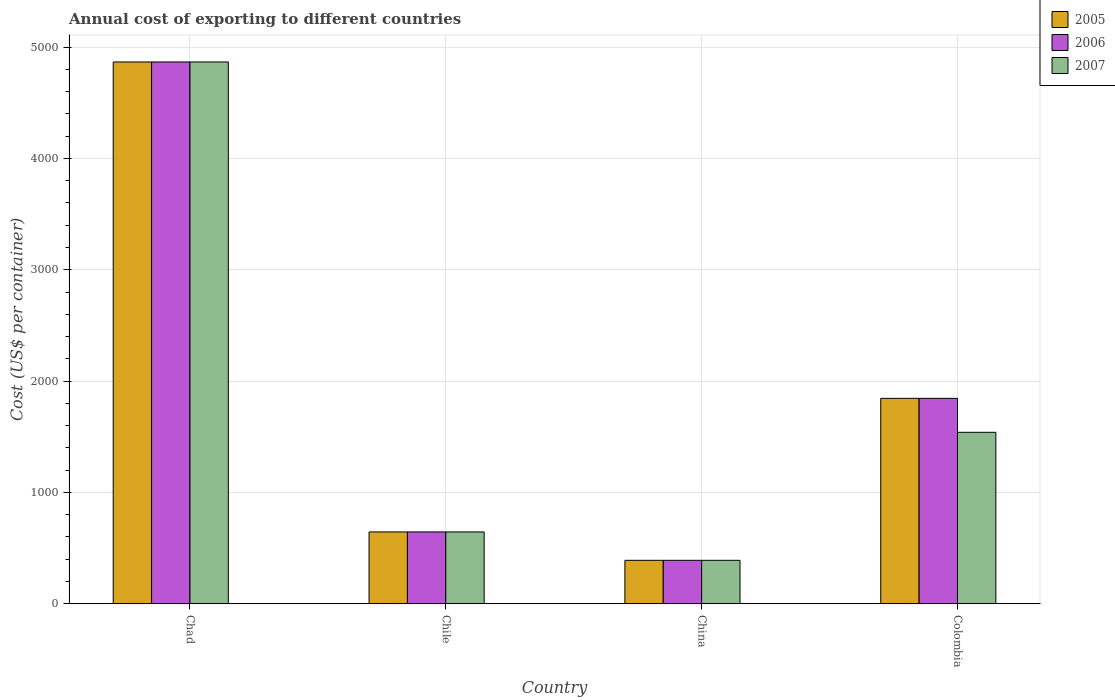How many different coloured bars are there?
Your answer should be compact. 3. How many groups of bars are there?
Offer a terse response. 4. Are the number of bars on each tick of the X-axis equal?
Make the answer very short. Yes. How many bars are there on the 4th tick from the left?
Give a very brief answer. 3. What is the label of the 1st group of bars from the left?
Make the answer very short. Chad. In how many cases, is the number of bars for a given country not equal to the number of legend labels?
Offer a very short reply. 0. What is the total annual cost of exporting in 2006 in Colombia?
Give a very brief answer. 1845. Across all countries, what is the maximum total annual cost of exporting in 2007?
Your answer should be compact. 4867. Across all countries, what is the minimum total annual cost of exporting in 2006?
Your answer should be compact. 390. In which country was the total annual cost of exporting in 2007 maximum?
Provide a short and direct response. Chad. In which country was the total annual cost of exporting in 2007 minimum?
Provide a short and direct response. China. What is the total total annual cost of exporting in 2007 in the graph?
Your response must be concise. 7442. What is the difference between the total annual cost of exporting in 2006 in Chile and that in China?
Your response must be concise. 255. What is the difference between the total annual cost of exporting in 2005 in Chad and the total annual cost of exporting in 2006 in Chile?
Make the answer very short. 4222. What is the average total annual cost of exporting in 2007 per country?
Provide a short and direct response. 1860.5. What is the ratio of the total annual cost of exporting in 2005 in Chad to that in China?
Offer a very short reply. 12.48. Is the total annual cost of exporting in 2006 in Chad less than that in China?
Ensure brevity in your answer.  No. What is the difference between the highest and the second highest total annual cost of exporting in 2007?
Your response must be concise. 3327. What is the difference between the highest and the lowest total annual cost of exporting in 2007?
Give a very brief answer. 4477. In how many countries, is the total annual cost of exporting in 2006 greater than the average total annual cost of exporting in 2006 taken over all countries?
Give a very brief answer. 1. Is the sum of the total annual cost of exporting in 2007 in China and Colombia greater than the maximum total annual cost of exporting in 2005 across all countries?
Provide a short and direct response. No. Is it the case that in every country, the sum of the total annual cost of exporting in 2007 and total annual cost of exporting in 2005 is greater than the total annual cost of exporting in 2006?
Keep it short and to the point. Yes. Are all the bars in the graph horizontal?
Give a very brief answer. No. What is the title of the graph?
Make the answer very short. Annual cost of exporting to different countries. What is the label or title of the X-axis?
Your response must be concise. Country. What is the label or title of the Y-axis?
Your answer should be very brief. Cost (US$ per container). What is the Cost (US$ per container) in 2005 in Chad?
Give a very brief answer. 4867. What is the Cost (US$ per container) in 2006 in Chad?
Provide a short and direct response. 4867. What is the Cost (US$ per container) in 2007 in Chad?
Make the answer very short. 4867. What is the Cost (US$ per container) in 2005 in Chile?
Your answer should be compact. 645. What is the Cost (US$ per container) of 2006 in Chile?
Your answer should be compact. 645. What is the Cost (US$ per container) of 2007 in Chile?
Give a very brief answer. 645. What is the Cost (US$ per container) in 2005 in China?
Ensure brevity in your answer.  390. What is the Cost (US$ per container) of 2006 in China?
Your response must be concise. 390. What is the Cost (US$ per container) in 2007 in China?
Make the answer very short. 390. What is the Cost (US$ per container) in 2005 in Colombia?
Your answer should be compact. 1845. What is the Cost (US$ per container) of 2006 in Colombia?
Provide a short and direct response. 1845. What is the Cost (US$ per container) in 2007 in Colombia?
Your response must be concise. 1540. Across all countries, what is the maximum Cost (US$ per container) in 2005?
Your answer should be very brief. 4867. Across all countries, what is the maximum Cost (US$ per container) of 2006?
Your answer should be very brief. 4867. Across all countries, what is the maximum Cost (US$ per container) of 2007?
Your answer should be very brief. 4867. Across all countries, what is the minimum Cost (US$ per container) of 2005?
Offer a very short reply. 390. Across all countries, what is the minimum Cost (US$ per container) in 2006?
Provide a short and direct response. 390. Across all countries, what is the minimum Cost (US$ per container) of 2007?
Provide a succinct answer. 390. What is the total Cost (US$ per container) in 2005 in the graph?
Provide a short and direct response. 7747. What is the total Cost (US$ per container) of 2006 in the graph?
Your answer should be compact. 7747. What is the total Cost (US$ per container) in 2007 in the graph?
Offer a very short reply. 7442. What is the difference between the Cost (US$ per container) in 2005 in Chad and that in Chile?
Your answer should be compact. 4222. What is the difference between the Cost (US$ per container) in 2006 in Chad and that in Chile?
Provide a succinct answer. 4222. What is the difference between the Cost (US$ per container) of 2007 in Chad and that in Chile?
Your answer should be compact. 4222. What is the difference between the Cost (US$ per container) in 2005 in Chad and that in China?
Your response must be concise. 4477. What is the difference between the Cost (US$ per container) of 2006 in Chad and that in China?
Give a very brief answer. 4477. What is the difference between the Cost (US$ per container) in 2007 in Chad and that in China?
Give a very brief answer. 4477. What is the difference between the Cost (US$ per container) of 2005 in Chad and that in Colombia?
Ensure brevity in your answer.  3022. What is the difference between the Cost (US$ per container) in 2006 in Chad and that in Colombia?
Ensure brevity in your answer.  3022. What is the difference between the Cost (US$ per container) in 2007 in Chad and that in Colombia?
Make the answer very short. 3327. What is the difference between the Cost (US$ per container) of 2005 in Chile and that in China?
Offer a terse response. 255. What is the difference between the Cost (US$ per container) in 2006 in Chile and that in China?
Ensure brevity in your answer.  255. What is the difference between the Cost (US$ per container) in 2007 in Chile and that in China?
Make the answer very short. 255. What is the difference between the Cost (US$ per container) in 2005 in Chile and that in Colombia?
Offer a very short reply. -1200. What is the difference between the Cost (US$ per container) in 2006 in Chile and that in Colombia?
Your response must be concise. -1200. What is the difference between the Cost (US$ per container) in 2007 in Chile and that in Colombia?
Your answer should be compact. -895. What is the difference between the Cost (US$ per container) of 2005 in China and that in Colombia?
Keep it short and to the point. -1455. What is the difference between the Cost (US$ per container) in 2006 in China and that in Colombia?
Keep it short and to the point. -1455. What is the difference between the Cost (US$ per container) of 2007 in China and that in Colombia?
Provide a short and direct response. -1150. What is the difference between the Cost (US$ per container) in 2005 in Chad and the Cost (US$ per container) in 2006 in Chile?
Your response must be concise. 4222. What is the difference between the Cost (US$ per container) in 2005 in Chad and the Cost (US$ per container) in 2007 in Chile?
Provide a short and direct response. 4222. What is the difference between the Cost (US$ per container) of 2006 in Chad and the Cost (US$ per container) of 2007 in Chile?
Provide a short and direct response. 4222. What is the difference between the Cost (US$ per container) of 2005 in Chad and the Cost (US$ per container) of 2006 in China?
Provide a short and direct response. 4477. What is the difference between the Cost (US$ per container) in 2005 in Chad and the Cost (US$ per container) in 2007 in China?
Offer a very short reply. 4477. What is the difference between the Cost (US$ per container) in 2006 in Chad and the Cost (US$ per container) in 2007 in China?
Ensure brevity in your answer.  4477. What is the difference between the Cost (US$ per container) in 2005 in Chad and the Cost (US$ per container) in 2006 in Colombia?
Make the answer very short. 3022. What is the difference between the Cost (US$ per container) of 2005 in Chad and the Cost (US$ per container) of 2007 in Colombia?
Give a very brief answer. 3327. What is the difference between the Cost (US$ per container) in 2006 in Chad and the Cost (US$ per container) in 2007 in Colombia?
Provide a succinct answer. 3327. What is the difference between the Cost (US$ per container) in 2005 in Chile and the Cost (US$ per container) in 2006 in China?
Give a very brief answer. 255. What is the difference between the Cost (US$ per container) of 2005 in Chile and the Cost (US$ per container) of 2007 in China?
Keep it short and to the point. 255. What is the difference between the Cost (US$ per container) of 2006 in Chile and the Cost (US$ per container) of 2007 in China?
Keep it short and to the point. 255. What is the difference between the Cost (US$ per container) of 2005 in Chile and the Cost (US$ per container) of 2006 in Colombia?
Your answer should be very brief. -1200. What is the difference between the Cost (US$ per container) in 2005 in Chile and the Cost (US$ per container) in 2007 in Colombia?
Your response must be concise. -895. What is the difference between the Cost (US$ per container) of 2006 in Chile and the Cost (US$ per container) of 2007 in Colombia?
Your answer should be very brief. -895. What is the difference between the Cost (US$ per container) of 2005 in China and the Cost (US$ per container) of 2006 in Colombia?
Ensure brevity in your answer.  -1455. What is the difference between the Cost (US$ per container) of 2005 in China and the Cost (US$ per container) of 2007 in Colombia?
Give a very brief answer. -1150. What is the difference between the Cost (US$ per container) in 2006 in China and the Cost (US$ per container) in 2007 in Colombia?
Keep it short and to the point. -1150. What is the average Cost (US$ per container) in 2005 per country?
Keep it short and to the point. 1936.75. What is the average Cost (US$ per container) of 2006 per country?
Your answer should be very brief. 1936.75. What is the average Cost (US$ per container) of 2007 per country?
Give a very brief answer. 1860.5. What is the difference between the Cost (US$ per container) in 2005 and Cost (US$ per container) in 2006 in Chad?
Provide a short and direct response. 0. What is the difference between the Cost (US$ per container) in 2005 and Cost (US$ per container) in 2007 in Chad?
Your response must be concise. 0. What is the difference between the Cost (US$ per container) of 2005 and Cost (US$ per container) of 2006 in Chile?
Give a very brief answer. 0. What is the difference between the Cost (US$ per container) in 2005 and Cost (US$ per container) in 2007 in Chile?
Keep it short and to the point. 0. What is the difference between the Cost (US$ per container) of 2006 and Cost (US$ per container) of 2007 in Chile?
Provide a succinct answer. 0. What is the difference between the Cost (US$ per container) in 2005 and Cost (US$ per container) in 2007 in Colombia?
Ensure brevity in your answer.  305. What is the difference between the Cost (US$ per container) in 2006 and Cost (US$ per container) in 2007 in Colombia?
Ensure brevity in your answer.  305. What is the ratio of the Cost (US$ per container) in 2005 in Chad to that in Chile?
Ensure brevity in your answer.  7.55. What is the ratio of the Cost (US$ per container) in 2006 in Chad to that in Chile?
Your response must be concise. 7.55. What is the ratio of the Cost (US$ per container) of 2007 in Chad to that in Chile?
Provide a short and direct response. 7.55. What is the ratio of the Cost (US$ per container) in 2005 in Chad to that in China?
Ensure brevity in your answer.  12.48. What is the ratio of the Cost (US$ per container) in 2006 in Chad to that in China?
Offer a very short reply. 12.48. What is the ratio of the Cost (US$ per container) in 2007 in Chad to that in China?
Provide a short and direct response. 12.48. What is the ratio of the Cost (US$ per container) of 2005 in Chad to that in Colombia?
Provide a short and direct response. 2.64. What is the ratio of the Cost (US$ per container) in 2006 in Chad to that in Colombia?
Offer a very short reply. 2.64. What is the ratio of the Cost (US$ per container) in 2007 in Chad to that in Colombia?
Ensure brevity in your answer.  3.16. What is the ratio of the Cost (US$ per container) in 2005 in Chile to that in China?
Provide a succinct answer. 1.65. What is the ratio of the Cost (US$ per container) of 2006 in Chile to that in China?
Your answer should be very brief. 1.65. What is the ratio of the Cost (US$ per container) of 2007 in Chile to that in China?
Your answer should be compact. 1.65. What is the ratio of the Cost (US$ per container) in 2005 in Chile to that in Colombia?
Ensure brevity in your answer.  0.35. What is the ratio of the Cost (US$ per container) of 2006 in Chile to that in Colombia?
Your answer should be very brief. 0.35. What is the ratio of the Cost (US$ per container) of 2007 in Chile to that in Colombia?
Give a very brief answer. 0.42. What is the ratio of the Cost (US$ per container) of 2005 in China to that in Colombia?
Offer a very short reply. 0.21. What is the ratio of the Cost (US$ per container) in 2006 in China to that in Colombia?
Your response must be concise. 0.21. What is the ratio of the Cost (US$ per container) in 2007 in China to that in Colombia?
Ensure brevity in your answer.  0.25. What is the difference between the highest and the second highest Cost (US$ per container) in 2005?
Offer a terse response. 3022. What is the difference between the highest and the second highest Cost (US$ per container) in 2006?
Offer a very short reply. 3022. What is the difference between the highest and the second highest Cost (US$ per container) in 2007?
Offer a terse response. 3327. What is the difference between the highest and the lowest Cost (US$ per container) in 2005?
Provide a succinct answer. 4477. What is the difference between the highest and the lowest Cost (US$ per container) of 2006?
Your answer should be compact. 4477. What is the difference between the highest and the lowest Cost (US$ per container) in 2007?
Offer a very short reply. 4477. 